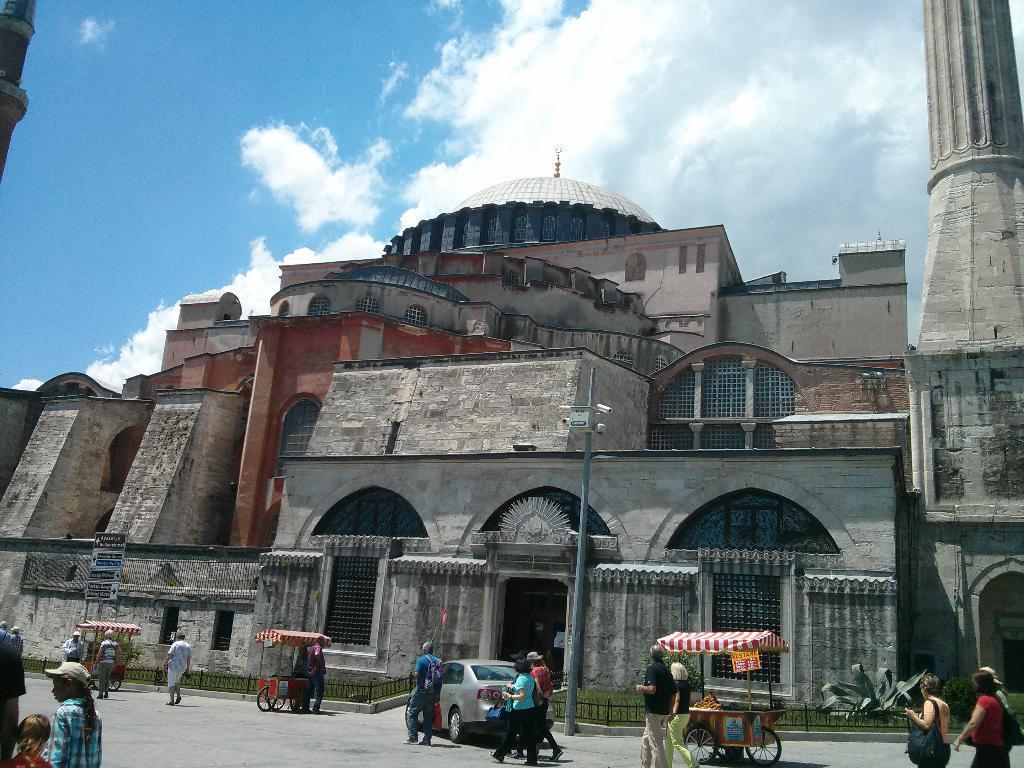In one or two sentences, can you explain what this image depicts? In the foreground of this image, there are people walking on the pavement. We can also see few cart like objects and a vehicle. In the background, there is a pole, grass, railing, building, sky and the cloud. 